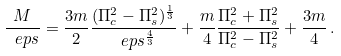<formula> <loc_0><loc_0><loc_500><loc_500>\frac { M } { \ e p s } = \frac { 3 m } { 2 } \frac { ( \Pi _ { c } ^ { 2 } - \Pi _ { s } ^ { 2 } ) ^ { \frac { 1 } { 3 } } } { \ e p s ^ { \frac { 4 } { 3 } } } + \frac { m } { 4 } \frac { \Pi _ { c } ^ { 2 } + \Pi _ { s } ^ { 2 } } { \Pi _ { c } ^ { 2 } - \Pi _ { s } ^ { 2 } } + \frac { 3 m } { 4 } \, .</formula> 